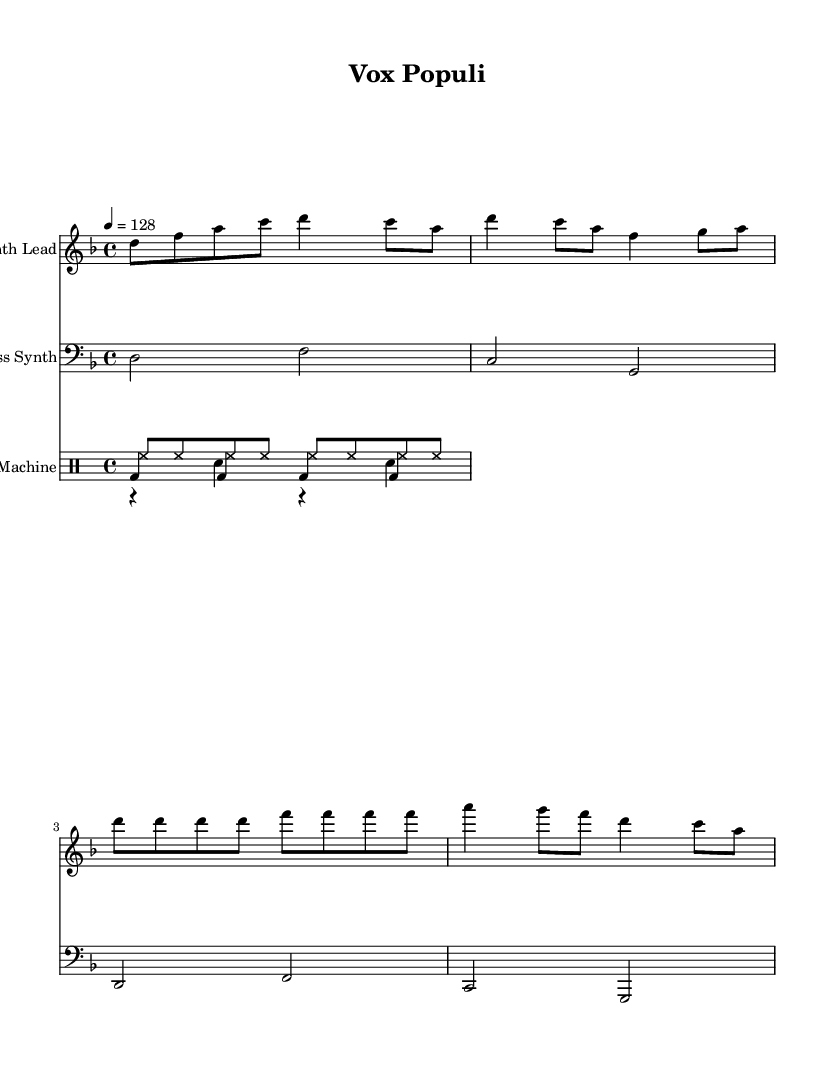What is the key signature of this music? The key signature is D minor, which has one flat (B flat). This can be determined by looking at the key signature indicated at the beginning of the staff, which shows one flat sign.
Answer: D minor What is the time signature of this music? The time signature is 4/4, which can be identified by the fraction notation shown at the beginning of the piece. The top number indicates there are four beats in each measure, and the bottom number indicates that a quarter note gets one beat.
Answer: 4/4 What is the tempo marking for this piece? The tempo marking is 128 beats per minute, which is indicated in the tempo text at the start of the music. This means that the music should be played at a moderate upbeat speed.
Answer: 128 How many measures are in the Synth Lead part? There are 5 measures in the Synth Lead part. This can be determined by counting the number of vertical bar lines present in the stave for the Synth Lead section.
Answer: 5 What is the predominant instrument type used in this composition? The predominant instrument type is electronic. This is evident from the instrument names such as "Synth Lead" and "Bass Synth," which refer to electronic sound generation rather than traditional acoustic instruments.
Answer: electronic What type of rhythm pattern is repeated in the Drum Machine part? The rhythm pattern in the Drum Machine part features a consistent kick drum and snare pattern every measure, with high-hats in a continuous eighth-note rhythm. The kick drum plays on every beat, and the snare alternates, making it a common electronic dance beat.
Answer: kick and snare 